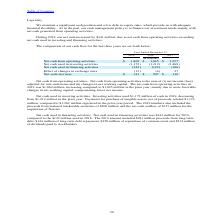According to Stmicroelectronics's financial document, What led to increase in net cash from operating activities in 2019? mainly due to more favorable changes in net working capital, compensating lower net income.. The document states: "sing compared to $1,845 million in the prior year, mainly due to more favorable changes in net working capital, compensating lower net income...." Also, What was the value of proceeds from matured marketable securities in 2019? According to the financial document, $200 million. The relevant text states: "the proceeds from matured marketable securities of $200 million and the net cash outflow of $127 million for the acquisition of Norstel...." Also, What was the value of Net cash used in financing activities  in 2019? According to the financial document, $343 million. The relevant text states: "vities . Net cash used in financing activities was $343 million for 2019, compared to the $122 million used in 2018. The 2019 amount included $281 million proceeds..." Also, can you calculate: What is the increase/ (decrease) in Net cash from operating activities from the period 2017 to 2019? Based on the calculation: 1,869-1,677, the result is 192 (in millions). This is based on the information: "cash from operating activities $ 1,869 $ 1,845 $ 1,677 Net cash from operating activities $ 1,869 $ 1,845 $ 1,677..." The key data points involved are: 1,677, 1,869. Also, can you calculate: What is the increase/ (decrease) in Net cash used in investing activities from the period 2017 to 2019? Based on the calculation: 1,172-1,468, the result is -296 (in millions). This is based on the information: "Net cash used in investing activities (1,172) (1,212) (1,468) ash used in investing activities (1,172) (1,212) (1,468)..." The key data points involved are: 1,172, 1,468. Also, can you calculate: What is the increase/ (decrease) in Net cash used in financing activities from the period 2017 to 2019? Based on the calculation: 343-106, the result is 237 (in millions). This is based on the information: "Net cash used in financing activities (343) (122) (106) et cash used in financing activities (343) (122) (106)..." The key data points involved are: 106, 343. 